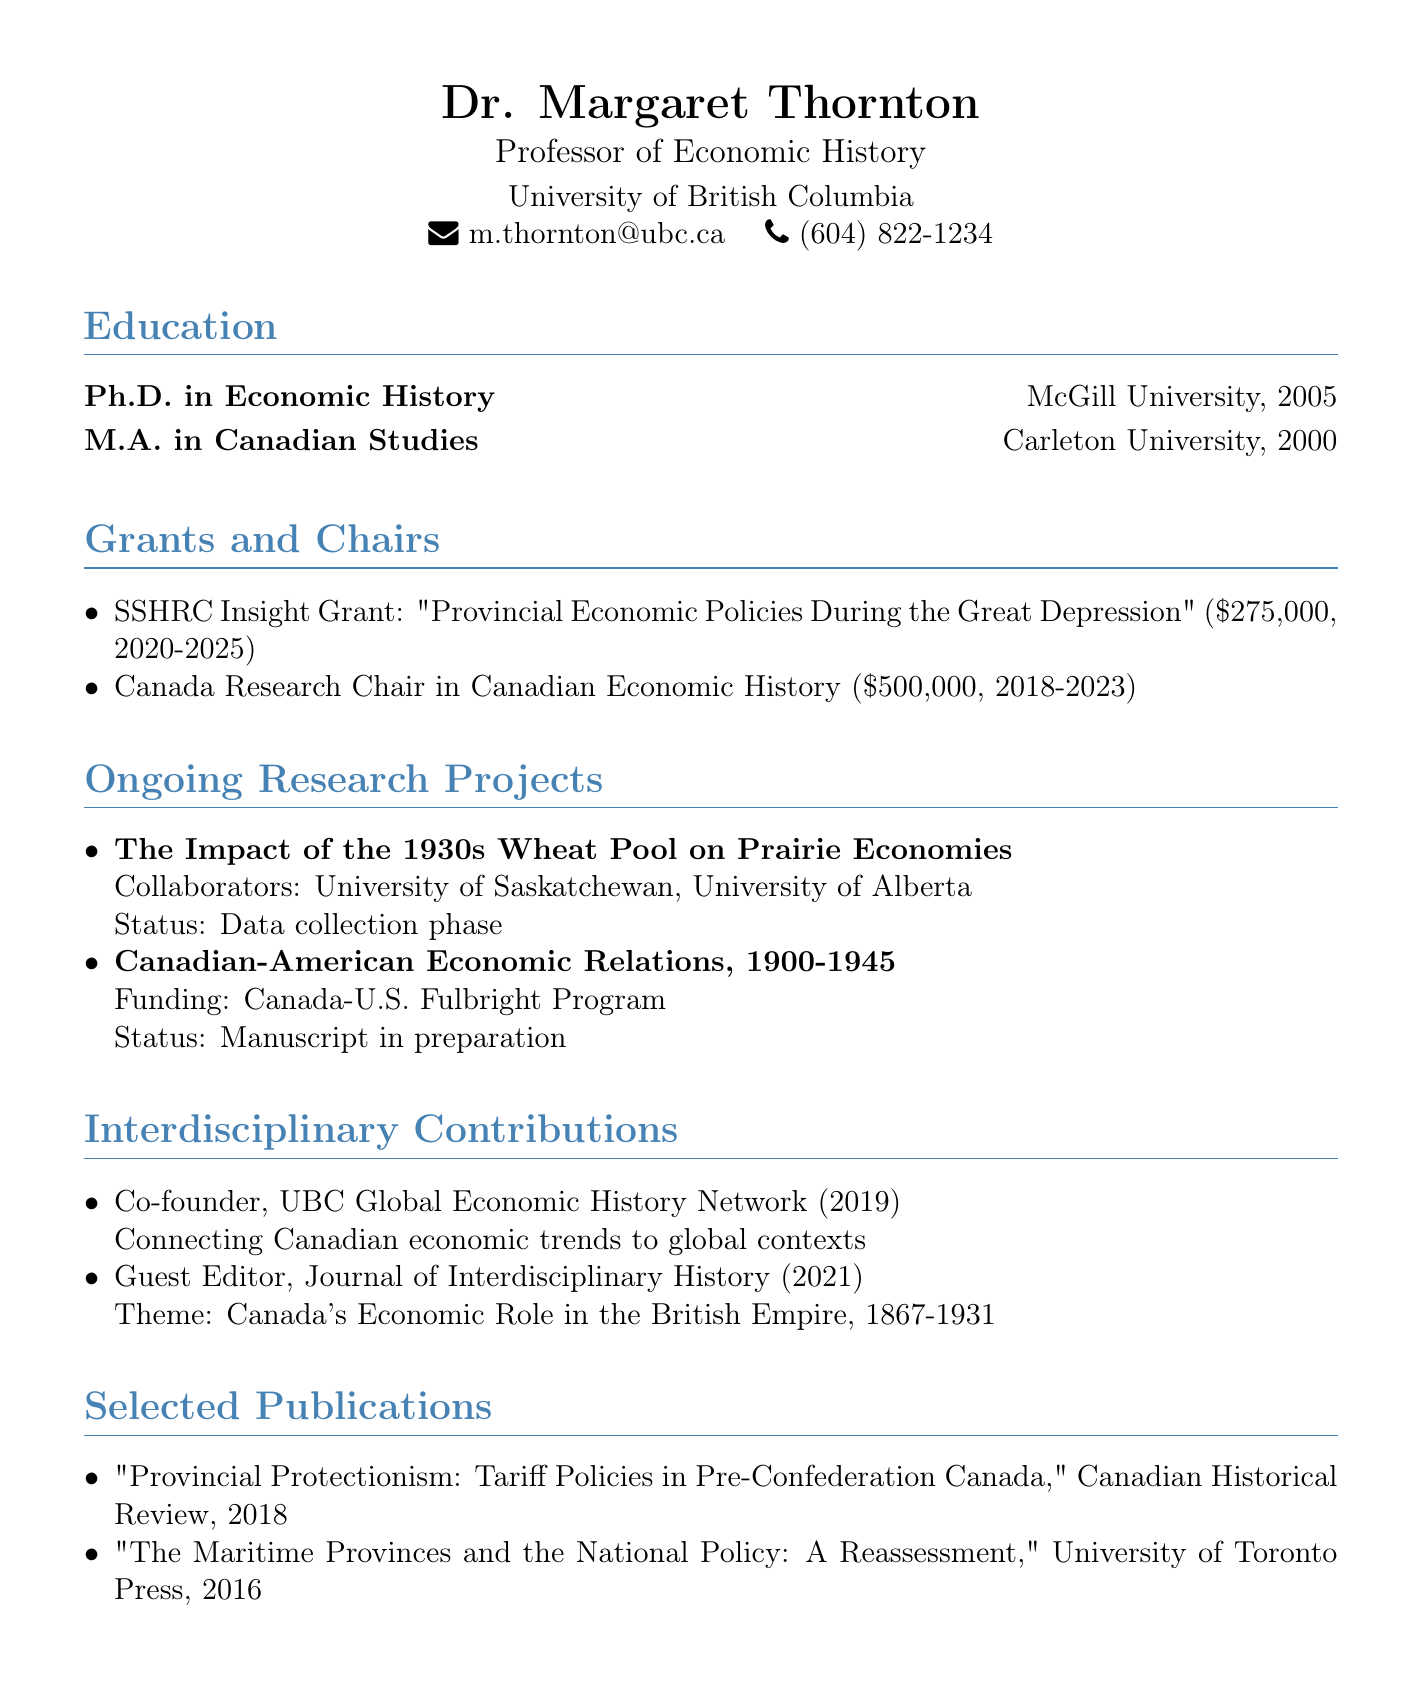what is the name of the professor? The document provides the name of the professor as Dr. Margaret Thornton.
Answer: Dr. Margaret Thornton which institution is Dr. Thornton affiliated with? The document specifies the institution as the University of British Columbia.
Answer: University of British Columbia how much funding did Dr. Thornton receive for the SSHRC Insight Grant? The document states the amount for the SSHRC Insight Grant as $275,000.
Answer: $275,000 what is the status of the research project on Canadian-American Economic Relations, 1900-1945? The document indicates the status as "Manuscript in preparation."
Answer: Manuscript in preparation in what year was the UBC Global Economic History Network co-founded? The document mentions the founding year of the UBC Global Economic History Network as 2019.
Answer: 2019 how many grants are listed in the document? The document lists two grants that Dr. Thornton received.
Answer: 2 what is the theme of the Journal of Interdisciplinary History that Dr. Thornton guest-edited? The document describes the theme as "Canada's Economic Role in the British Empire, 1867-1931."
Answer: Canada's Economic Role in the British Empire, 1867-1931 which award did Dr. Thornton receive from the Canada-U.S. Fulbright Program? The document states the funding source for the project is the Canada-U.S. Fulbright Program.
Answer: Canada-U.S. Fulbright Program 